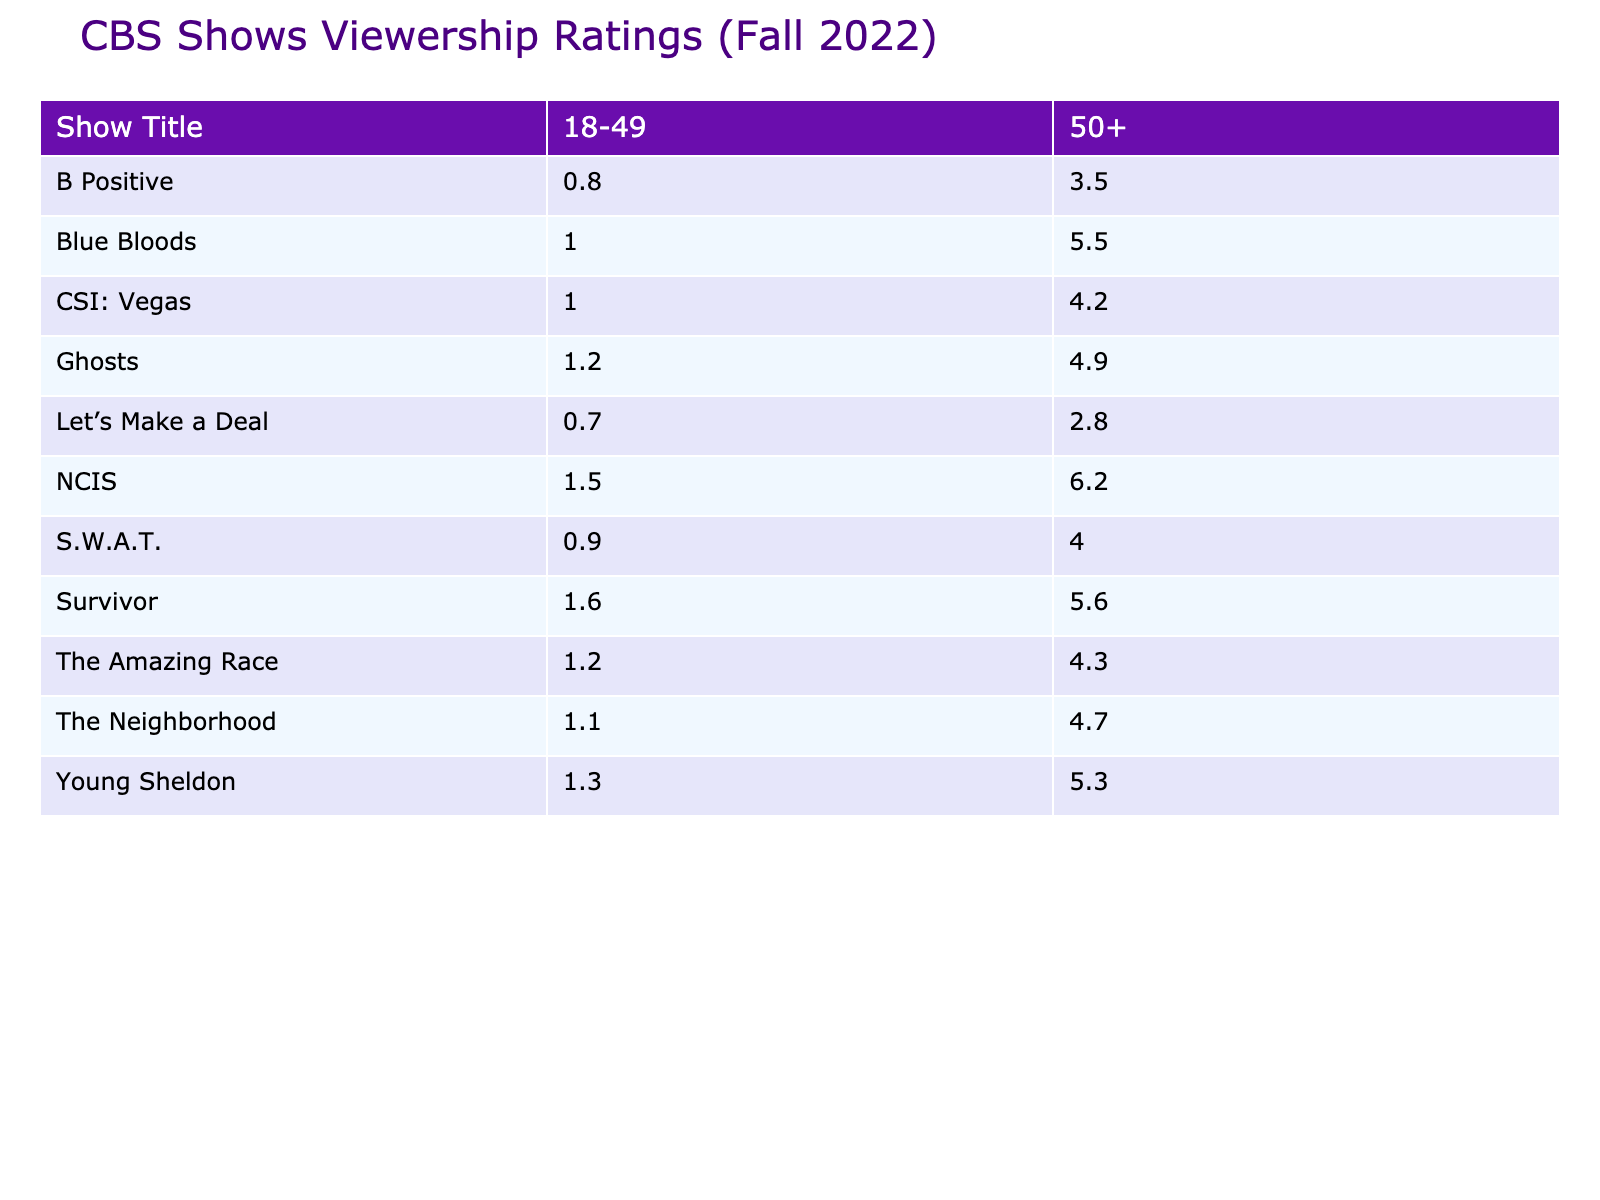What is the viewership for "NCIS" among the 50+ demographic? The viewership for "NCIS" in the 50+ demographic is directly listed in the table under that column, which shows 6.2 million.
Answer: 6.2 million Which show has the lowest viewership in the 18-49 demographic? By looking at the 18-49 column in the table, "B Positive" has the lowest value at 0.8 million.
Answer: B Positive What is the total viewership for "Survivor" across both demographics? To find the total viewership for "Survivor," add the values from both demographics: 1.6 million (18-49) + 5.6 million (50+) = 7.2 million.
Answer: 7.2 million Did "CSI: Vegas" have a higher viewership in the 50+ demographic compared to "The Amazing Race"? "CSI: Vegas" has a viewership of 4.2 million in the 50+ demographic, while "The Amazing Race" has 4.3 million. Since 4.2 million < 4.3 million, "CSI: Vegas" did not have a higher viewership.
Answer: No What is the average viewership for the shows in the 18-49 demographic? The total viewership for the 18-49 demographic is 1.5 + 1.3 + 1.2 + 1.1 + 1.0 + 0.9 + 0.8 + 1.0 + 0.7 + 1.6 + 1.2 = 12.3 million. There are 11 shows, so the average is 12.3/11 = 1.12 million.
Answer: 1.12 million Which show had a significant viewership drop from the 50+ demographic to the 18-49 demographic? Comparing the viewership values: "Blue Bloods" has 5.5 million (50+) and only 1.0 million (18-49), showing a significant drop of 4.5 million.
Answer: Blue Bloods How many shows had viewership greater than 5 million in the 50+ demographic? Checking the 50+ column, the shows with viewership greater than 5 million are "NCIS" (6.2), "Survivor" (5.6), and "Blue Bloods" (5.5). This counts to a total of 3 shows.
Answer: 3 shows What is the difference in viewership for "Ghosts" between the two demographics? The viewership for "Ghosts" in the 18-49 demographic is 1.2 million, and in the 50+ demographic, it is 4.9 million. The difference is 4.9 - 1.2 = 3.7 million.
Answer: 3.7 million Is the viewership of "Young Sheldon" in the 50+ demographic higher than that of "B Positive" in the same demographic? "Young Sheldon" has a viewership of 5.3 million in the 50+ demographic whereas "B Positive" has 3.5 million. Since 5.3 million > 3.5 million, "Young Sheldon" is higher.
Answer: Yes What is the total viewership from the shows listed that aired on October 10, 2022? The only show that aired on this date is "Let’s Make a Deal" with a viewership of 0.7 million in the 18-49 demographic and 2.8 million in the 50+ demographic, summing up to 0.7 + 2.8 = 3.5 million.
Answer: 3.5 million 